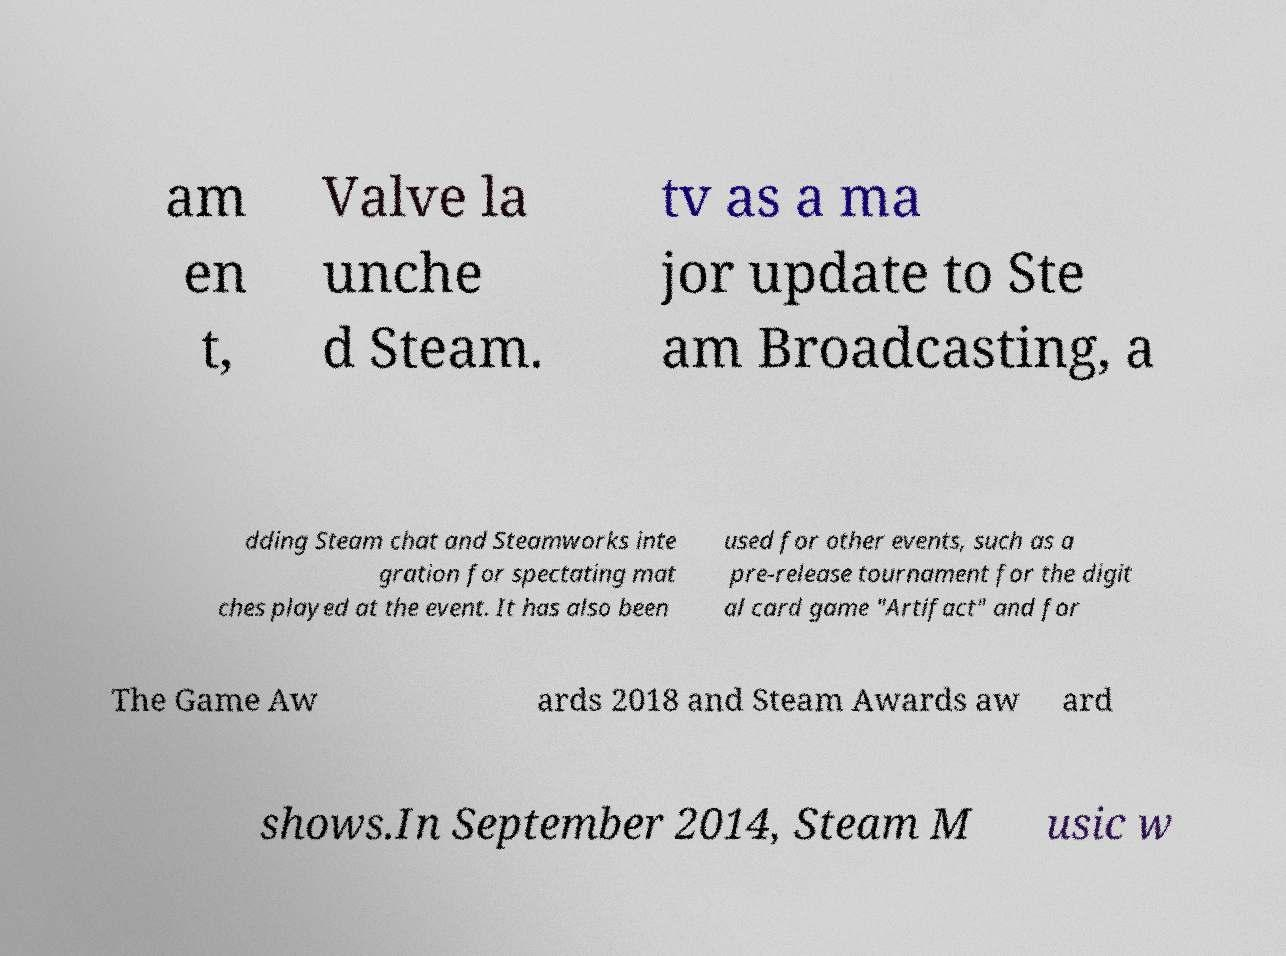There's text embedded in this image that I need extracted. Can you transcribe it verbatim? am en t, Valve la unche d Steam. tv as a ma jor update to Ste am Broadcasting, a dding Steam chat and Steamworks inte gration for spectating mat ches played at the event. It has also been used for other events, such as a pre-release tournament for the digit al card game "Artifact" and for The Game Aw ards 2018 and Steam Awards aw ard shows.In September 2014, Steam M usic w 